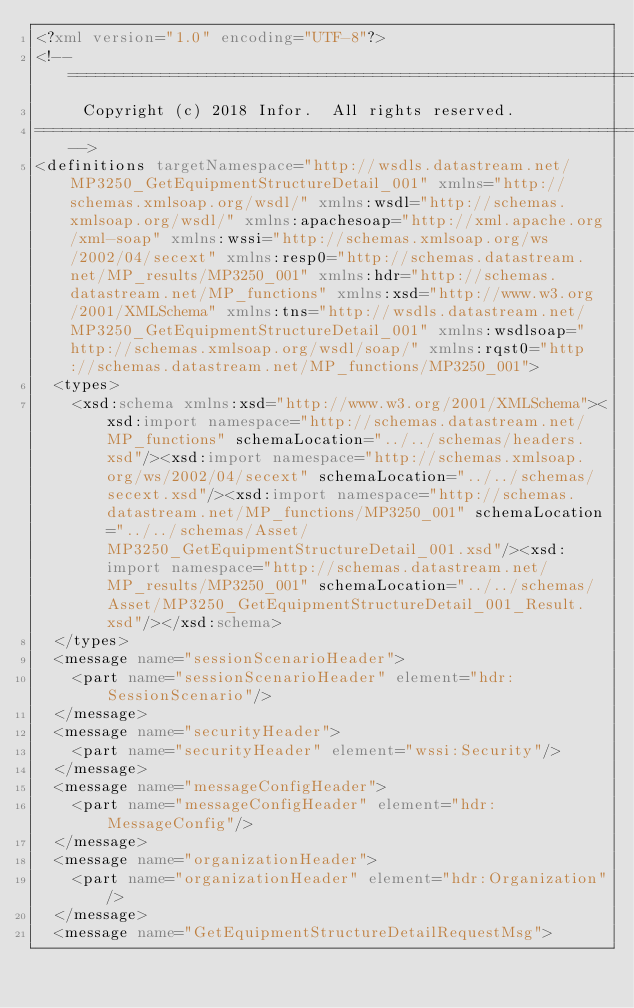<code> <loc_0><loc_0><loc_500><loc_500><_XML_><?xml version="1.0" encoding="UTF-8"?>
<!-- ================================================================================
     Copyright (c) 2018 Infor.  All rights reserved. 
==================================================================================-->
<definitions targetNamespace="http://wsdls.datastream.net/MP3250_GetEquipmentStructureDetail_001" xmlns="http://schemas.xmlsoap.org/wsdl/" xmlns:wsdl="http://schemas.xmlsoap.org/wsdl/" xmlns:apachesoap="http://xml.apache.org/xml-soap" xmlns:wssi="http://schemas.xmlsoap.org/ws/2002/04/secext" xmlns:resp0="http://schemas.datastream.net/MP_results/MP3250_001" xmlns:hdr="http://schemas.datastream.net/MP_functions" xmlns:xsd="http://www.w3.org/2001/XMLSchema" xmlns:tns="http://wsdls.datastream.net/MP3250_GetEquipmentStructureDetail_001" xmlns:wsdlsoap="http://schemas.xmlsoap.org/wsdl/soap/" xmlns:rqst0="http://schemas.datastream.net/MP_functions/MP3250_001">
  <types>
    <xsd:schema xmlns:xsd="http://www.w3.org/2001/XMLSchema"><xsd:import namespace="http://schemas.datastream.net/MP_functions" schemaLocation="../../schemas/headers.xsd"/><xsd:import namespace="http://schemas.xmlsoap.org/ws/2002/04/secext" schemaLocation="../../schemas/secext.xsd"/><xsd:import namespace="http://schemas.datastream.net/MP_functions/MP3250_001" schemaLocation="../../schemas/Asset/MP3250_GetEquipmentStructureDetail_001.xsd"/><xsd:import namespace="http://schemas.datastream.net/MP_results/MP3250_001" schemaLocation="../../schemas/Asset/MP3250_GetEquipmentStructureDetail_001_Result.xsd"/></xsd:schema>
  </types>
  <message name="sessionScenarioHeader">
    <part name="sessionScenarioHeader" element="hdr:SessionScenario"/>
  </message>
  <message name="securityHeader">
    <part name="securityHeader" element="wssi:Security"/>
  </message>
  <message name="messageConfigHeader">
    <part name="messageConfigHeader" element="hdr:MessageConfig"/>
  </message>
  <message name="organizationHeader">
    <part name="organizationHeader" element="hdr:Organization"/>
  </message>
  <message name="GetEquipmentStructureDetailRequestMsg"></code> 